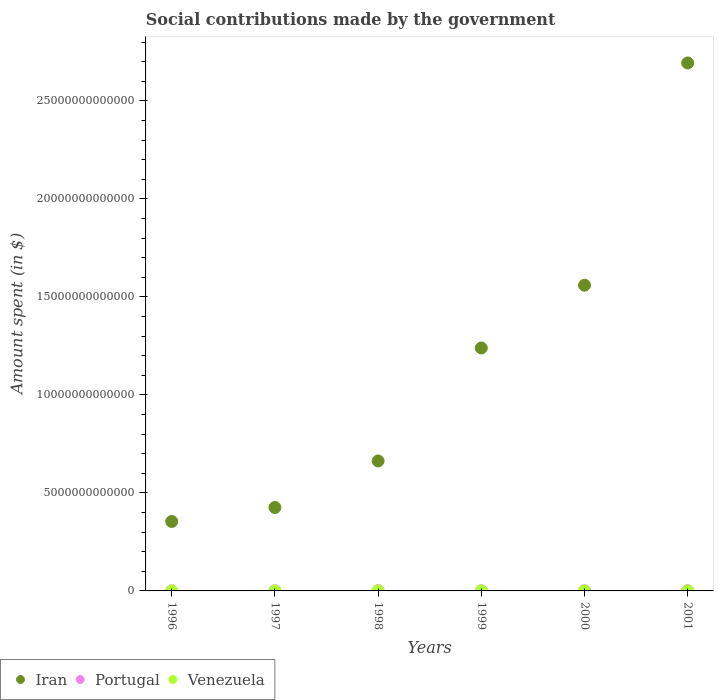How many different coloured dotlines are there?
Ensure brevity in your answer.  3. What is the amount spent on social contributions in Venezuela in 2000?
Offer a very short reply. 5.91e+08. Across all years, what is the maximum amount spent on social contributions in Portugal?
Provide a short and direct response. 1.42e+1. Across all years, what is the minimum amount spent on social contributions in Iran?
Give a very brief answer. 3.54e+12. What is the total amount spent on social contributions in Portugal in the graph?
Offer a very short reply. 6.99e+1. What is the difference between the amount spent on social contributions in Portugal in 1998 and that in 2001?
Make the answer very short. -3.02e+09. What is the difference between the amount spent on social contributions in Iran in 1999 and the amount spent on social contributions in Portugal in 2000?
Your response must be concise. 1.24e+13. What is the average amount spent on social contributions in Iran per year?
Your response must be concise. 1.16e+13. In the year 2001, what is the difference between the amount spent on social contributions in Portugal and amount spent on social contributions in Venezuela?
Your answer should be very brief. 1.36e+1. What is the ratio of the amount spent on social contributions in Venezuela in 1997 to that in 1999?
Your response must be concise. 0.33. Is the amount spent on social contributions in Portugal in 1997 less than that in 1999?
Offer a terse response. Yes. What is the difference between the highest and the second highest amount spent on social contributions in Portugal?
Offer a very short reply. 9.82e+08. What is the difference between the highest and the lowest amount spent on social contributions in Portugal?
Your answer should be very brief. 5.11e+09. In how many years, is the amount spent on social contributions in Iran greater than the average amount spent on social contributions in Iran taken over all years?
Ensure brevity in your answer.  3. Is the sum of the amount spent on social contributions in Iran in 2000 and 2001 greater than the maximum amount spent on social contributions in Portugal across all years?
Provide a short and direct response. Yes. Is the amount spent on social contributions in Venezuela strictly less than the amount spent on social contributions in Iran over the years?
Your answer should be compact. Yes. How many years are there in the graph?
Your response must be concise. 6. What is the difference between two consecutive major ticks on the Y-axis?
Offer a terse response. 5.00e+12. Are the values on the major ticks of Y-axis written in scientific E-notation?
Offer a very short reply. No. Does the graph contain any zero values?
Provide a succinct answer. No. Does the graph contain grids?
Your response must be concise. No. What is the title of the graph?
Provide a short and direct response. Social contributions made by the government. Does "Faeroe Islands" appear as one of the legend labels in the graph?
Provide a succinct answer. No. What is the label or title of the X-axis?
Provide a short and direct response. Years. What is the label or title of the Y-axis?
Provide a succinct answer. Amount spent (in $). What is the Amount spent (in $) of Iran in 1996?
Your answer should be very brief. 3.54e+12. What is the Amount spent (in $) of Portugal in 1996?
Keep it short and to the point. 9.14e+09. What is the Amount spent (in $) in Venezuela in 1996?
Your answer should be compact. 9.45e+07. What is the Amount spent (in $) of Iran in 1997?
Provide a succinct answer. 4.26e+12. What is the Amount spent (in $) in Portugal in 1997?
Provide a succinct answer. 1.01e+1. What is the Amount spent (in $) in Venezuela in 1997?
Your response must be concise. 1.60e+08. What is the Amount spent (in $) of Iran in 1998?
Offer a terse response. 6.63e+12. What is the Amount spent (in $) of Portugal in 1998?
Keep it short and to the point. 1.12e+1. What is the Amount spent (in $) of Venezuela in 1998?
Offer a very short reply. 3.72e+08. What is the Amount spent (in $) of Iran in 1999?
Your answer should be very brief. 1.24e+13. What is the Amount spent (in $) of Portugal in 1999?
Your response must be concise. 1.19e+1. What is the Amount spent (in $) of Venezuela in 1999?
Offer a very short reply. 4.79e+08. What is the Amount spent (in $) of Iran in 2000?
Ensure brevity in your answer.  1.56e+13. What is the Amount spent (in $) of Portugal in 2000?
Offer a very short reply. 1.33e+1. What is the Amount spent (in $) of Venezuela in 2000?
Offer a very short reply. 5.91e+08. What is the Amount spent (in $) in Iran in 2001?
Give a very brief answer. 2.69e+13. What is the Amount spent (in $) of Portugal in 2001?
Offer a terse response. 1.42e+1. What is the Amount spent (in $) of Venezuela in 2001?
Your answer should be compact. 6.74e+08. Across all years, what is the maximum Amount spent (in $) of Iran?
Give a very brief answer. 2.69e+13. Across all years, what is the maximum Amount spent (in $) in Portugal?
Offer a terse response. 1.42e+1. Across all years, what is the maximum Amount spent (in $) of Venezuela?
Your response must be concise. 6.74e+08. Across all years, what is the minimum Amount spent (in $) in Iran?
Provide a succinct answer. 3.54e+12. Across all years, what is the minimum Amount spent (in $) in Portugal?
Offer a very short reply. 9.14e+09. Across all years, what is the minimum Amount spent (in $) in Venezuela?
Keep it short and to the point. 9.45e+07. What is the total Amount spent (in $) in Iran in the graph?
Provide a succinct answer. 6.94e+13. What is the total Amount spent (in $) in Portugal in the graph?
Ensure brevity in your answer.  6.99e+1. What is the total Amount spent (in $) of Venezuela in the graph?
Offer a terse response. 2.37e+09. What is the difference between the Amount spent (in $) in Iran in 1996 and that in 1997?
Your answer should be very brief. -7.13e+11. What is the difference between the Amount spent (in $) of Portugal in 1996 and that in 1997?
Make the answer very short. -9.70e+08. What is the difference between the Amount spent (in $) in Venezuela in 1996 and that in 1997?
Your response must be concise. -6.55e+07. What is the difference between the Amount spent (in $) of Iran in 1996 and that in 1998?
Offer a terse response. -3.09e+12. What is the difference between the Amount spent (in $) in Portugal in 1996 and that in 1998?
Ensure brevity in your answer.  -2.09e+09. What is the difference between the Amount spent (in $) of Venezuela in 1996 and that in 1998?
Offer a terse response. -2.78e+08. What is the difference between the Amount spent (in $) in Iran in 1996 and that in 1999?
Offer a very short reply. -8.85e+12. What is the difference between the Amount spent (in $) of Portugal in 1996 and that in 1999?
Offer a very short reply. -2.79e+09. What is the difference between the Amount spent (in $) in Venezuela in 1996 and that in 1999?
Make the answer very short. -3.85e+08. What is the difference between the Amount spent (in $) of Iran in 1996 and that in 2000?
Give a very brief answer. -1.21e+13. What is the difference between the Amount spent (in $) of Portugal in 1996 and that in 2000?
Keep it short and to the point. -4.13e+09. What is the difference between the Amount spent (in $) of Venezuela in 1996 and that in 2000?
Provide a short and direct response. -4.96e+08. What is the difference between the Amount spent (in $) in Iran in 1996 and that in 2001?
Give a very brief answer. -2.34e+13. What is the difference between the Amount spent (in $) of Portugal in 1996 and that in 2001?
Offer a terse response. -5.11e+09. What is the difference between the Amount spent (in $) in Venezuela in 1996 and that in 2001?
Provide a succinct answer. -5.79e+08. What is the difference between the Amount spent (in $) of Iran in 1997 and that in 1998?
Your answer should be compact. -2.38e+12. What is the difference between the Amount spent (in $) of Portugal in 1997 and that in 1998?
Provide a short and direct response. -1.12e+09. What is the difference between the Amount spent (in $) of Venezuela in 1997 and that in 1998?
Offer a very short reply. -2.12e+08. What is the difference between the Amount spent (in $) in Iran in 1997 and that in 1999?
Provide a short and direct response. -8.14e+12. What is the difference between the Amount spent (in $) in Portugal in 1997 and that in 1999?
Provide a short and direct response. -1.82e+09. What is the difference between the Amount spent (in $) of Venezuela in 1997 and that in 1999?
Provide a short and direct response. -3.19e+08. What is the difference between the Amount spent (in $) of Iran in 1997 and that in 2000?
Your response must be concise. -1.13e+13. What is the difference between the Amount spent (in $) in Portugal in 1997 and that in 2000?
Your response must be concise. -3.16e+09. What is the difference between the Amount spent (in $) in Venezuela in 1997 and that in 2000?
Ensure brevity in your answer.  -4.30e+08. What is the difference between the Amount spent (in $) of Iran in 1997 and that in 2001?
Your response must be concise. -2.27e+13. What is the difference between the Amount spent (in $) of Portugal in 1997 and that in 2001?
Provide a short and direct response. -4.14e+09. What is the difference between the Amount spent (in $) of Venezuela in 1997 and that in 2001?
Your answer should be compact. -5.14e+08. What is the difference between the Amount spent (in $) of Iran in 1998 and that in 1999?
Offer a terse response. -5.76e+12. What is the difference between the Amount spent (in $) in Portugal in 1998 and that in 1999?
Make the answer very short. -7.01e+08. What is the difference between the Amount spent (in $) of Venezuela in 1998 and that in 1999?
Your answer should be very brief. -1.07e+08. What is the difference between the Amount spent (in $) of Iran in 1998 and that in 2000?
Your answer should be compact. -8.97e+12. What is the difference between the Amount spent (in $) in Portugal in 1998 and that in 2000?
Your answer should be compact. -2.04e+09. What is the difference between the Amount spent (in $) in Venezuela in 1998 and that in 2000?
Keep it short and to the point. -2.18e+08. What is the difference between the Amount spent (in $) in Iran in 1998 and that in 2001?
Ensure brevity in your answer.  -2.03e+13. What is the difference between the Amount spent (in $) in Portugal in 1998 and that in 2001?
Your response must be concise. -3.02e+09. What is the difference between the Amount spent (in $) in Venezuela in 1998 and that in 2001?
Your response must be concise. -3.01e+08. What is the difference between the Amount spent (in $) of Iran in 1999 and that in 2000?
Provide a succinct answer. -3.20e+12. What is the difference between the Amount spent (in $) of Portugal in 1999 and that in 2000?
Ensure brevity in your answer.  -1.34e+09. What is the difference between the Amount spent (in $) of Venezuela in 1999 and that in 2000?
Ensure brevity in your answer.  -1.11e+08. What is the difference between the Amount spent (in $) in Iran in 1999 and that in 2001?
Your answer should be very brief. -1.45e+13. What is the difference between the Amount spent (in $) in Portugal in 1999 and that in 2001?
Provide a succinct answer. -2.32e+09. What is the difference between the Amount spent (in $) of Venezuela in 1999 and that in 2001?
Keep it short and to the point. -1.94e+08. What is the difference between the Amount spent (in $) of Iran in 2000 and that in 2001?
Offer a very short reply. -1.13e+13. What is the difference between the Amount spent (in $) in Portugal in 2000 and that in 2001?
Ensure brevity in your answer.  -9.82e+08. What is the difference between the Amount spent (in $) in Venezuela in 2000 and that in 2001?
Keep it short and to the point. -8.30e+07. What is the difference between the Amount spent (in $) of Iran in 1996 and the Amount spent (in $) of Portugal in 1997?
Provide a short and direct response. 3.53e+12. What is the difference between the Amount spent (in $) in Iran in 1996 and the Amount spent (in $) in Venezuela in 1997?
Your answer should be compact. 3.54e+12. What is the difference between the Amount spent (in $) in Portugal in 1996 and the Amount spent (in $) in Venezuela in 1997?
Offer a very short reply. 8.98e+09. What is the difference between the Amount spent (in $) in Iran in 1996 and the Amount spent (in $) in Portugal in 1998?
Give a very brief answer. 3.53e+12. What is the difference between the Amount spent (in $) of Iran in 1996 and the Amount spent (in $) of Venezuela in 1998?
Offer a very short reply. 3.54e+12. What is the difference between the Amount spent (in $) in Portugal in 1996 and the Amount spent (in $) in Venezuela in 1998?
Provide a succinct answer. 8.76e+09. What is the difference between the Amount spent (in $) in Iran in 1996 and the Amount spent (in $) in Portugal in 1999?
Make the answer very short. 3.53e+12. What is the difference between the Amount spent (in $) in Iran in 1996 and the Amount spent (in $) in Venezuela in 1999?
Keep it short and to the point. 3.54e+12. What is the difference between the Amount spent (in $) in Portugal in 1996 and the Amount spent (in $) in Venezuela in 1999?
Keep it short and to the point. 8.66e+09. What is the difference between the Amount spent (in $) in Iran in 1996 and the Amount spent (in $) in Portugal in 2000?
Provide a succinct answer. 3.53e+12. What is the difference between the Amount spent (in $) in Iran in 1996 and the Amount spent (in $) in Venezuela in 2000?
Give a very brief answer. 3.54e+12. What is the difference between the Amount spent (in $) of Portugal in 1996 and the Amount spent (in $) of Venezuela in 2000?
Provide a succinct answer. 8.55e+09. What is the difference between the Amount spent (in $) in Iran in 1996 and the Amount spent (in $) in Portugal in 2001?
Give a very brief answer. 3.53e+12. What is the difference between the Amount spent (in $) in Iran in 1996 and the Amount spent (in $) in Venezuela in 2001?
Provide a succinct answer. 3.54e+12. What is the difference between the Amount spent (in $) in Portugal in 1996 and the Amount spent (in $) in Venezuela in 2001?
Ensure brevity in your answer.  8.46e+09. What is the difference between the Amount spent (in $) in Iran in 1997 and the Amount spent (in $) in Portugal in 1998?
Make the answer very short. 4.25e+12. What is the difference between the Amount spent (in $) of Iran in 1997 and the Amount spent (in $) of Venezuela in 1998?
Your answer should be compact. 4.26e+12. What is the difference between the Amount spent (in $) of Portugal in 1997 and the Amount spent (in $) of Venezuela in 1998?
Provide a short and direct response. 9.74e+09. What is the difference between the Amount spent (in $) in Iran in 1997 and the Amount spent (in $) in Portugal in 1999?
Provide a succinct answer. 4.25e+12. What is the difference between the Amount spent (in $) in Iran in 1997 and the Amount spent (in $) in Venezuela in 1999?
Give a very brief answer. 4.26e+12. What is the difference between the Amount spent (in $) of Portugal in 1997 and the Amount spent (in $) of Venezuela in 1999?
Give a very brief answer. 9.63e+09. What is the difference between the Amount spent (in $) of Iran in 1997 and the Amount spent (in $) of Portugal in 2000?
Give a very brief answer. 4.24e+12. What is the difference between the Amount spent (in $) of Iran in 1997 and the Amount spent (in $) of Venezuela in 2000?
Your response must be concise. 4.26e+12. What is the difference between the Amount spent (in $) in Portugal in 1997 and the Amount spent (in $) in Venezuela in 2000?
Your answer should be compact. 9.52e+09. What is the difference between the Amount spent (in $) of Iran in 1997 and the Amount spent (in $) of Portugal in 2001?
Keep it short and to the point. 4.24e+12. What is the difference between the Amount spent (in $) in Iran in 1997 and the Amount spent (in $) in Venezuela in 2001?
Offer a terse response. 4.26e+12. What is the difference between the Amount spent (in $) in Portugal in 1997 and the Amount spent (in $) in Venezuela in 2001?
Offer a very short reply. 9.43e+09. What is the difference between the Amount spent (in $) of Iran in 1998 and the Amount spent (in $) of Portugal in 1999?
Your answer should be very brief. 6.62e+12. What is the difference between the Amount spent (in $) of Iran in 1998 and the Amount spent (in $) of Venezuela in 1999?
Ensure brevity in your answer.  6.63e+12. What is the difference between the Amount spent (in $) of Portugal in 1998 and the Amount spent (in $) of Venezuela in 1999?
Ensure brevity in your answer.  1.07e+1. What is the difference between the Amount spent (in $) in Iran in 1998 and the Amount spent (in $) in Portugal in 2000?
Offer a terse response. 6.62e+12. What is the difference between the Amount spent (in $) in Iran in 1998 and the Amount spent (in $) in Venezuela in 2000?
Provide a succinct answer. 6.63e+12. What is the difference between the Amount spent (in $) in Portugal in 1998 and the Amount spent (in $) in Venezuela in 2000?
Provide a succinct answer. 1.06e+1. What is the difference between the Amount spent (in $) of Iran in 1998 and the Amount spent (in $) of Portugal in 2001?
Ensure brevity in your answer.  6.62e+12. What is the difference between the Amount spent (in $) of Iran in 1998 and the Amount spent (in $) of Venezuela in 2001?
Offer a terse response. 6.63e+12. What is the difference between the Amount spent (in $) in Portugal in 1998 and the Amount spent (in $) in Venezuela in 2001?
Give a very brief answer. 1.06e+1. What is the difference between the Amount spent (in $) of Iran in 1999 and the Amount spent (in $) of Portugal in 2000?
Ensure brevity in your answer.  1.24e+13. What is the difference between the Amount spent (in $) of Iran in 1999 and the Amount spent (in $) of Venezuela in 2000?
Make the answer very short. 1.24e+13. What is the difference between the Amount spent (in $) in Portugal in 1999 and the Amount spent (in $) in Venezuela in 2000?
Your answer should be very brief. 1.13e+1. What is the difference between the Amount spent (in $) of Iran in 1999 and the Amount spent (in $) of Portugal in 2001?
Your answer should be compact. 1.24e+13. What is the difference between the Amount spent (in $) of Iran in 1999 and the Amount spent (in $) of Venezuela in 2001?
Your answer should be very brief. 1.24e+13. What is the difference between the Amount spent (in $) of Portugal in 1999 and the Amount spent (in $) of Venezuela in 2001?
Your answer should be very brief. 1.13e+1. What is the difference between the Amount spent (in $) of Iran in 2000 and the Amount spent (in $) of Portugal in 2001?
Your response must be concise. 1.56e+13. What is the difference between the Amount spent (in $) in Iran in 2000 and the Amount spent (in $) in Venezuela in 2001?
Give a very brief answer. 1.56e+13. What is the difference between the Amount spent (in $) in Portugal in 2000 and the Amount spent (in $) in Venezuela in 2001?
Offer a very short reply. 1.26e+1. What is the average Amount spent (in $) in Iran per year?
Make the answer very short. 1.16e+13. What is the average Amount spent (in $) of Portugal per year?
Make the answer very short. 1.17e+1. What is the average Amount spent (in $) of Venezuela per year?
Your answer should be very brief. 3.95e+08. In the year 1996, what is the difference between the Amount spent (in $) of Iran and Amount spent (in $) of Portugal?
Offer a terse response. 3.53e+12. In the year 1996, what is the difference between the Amount spent (in $) of Iran and Amount spent (in $) of Venezuela?
Your response must be concise. 3.54e+12. In the year 1996, what is the difference between the Amount spent (in $) of Portugal and Amount spent (in $) of Venezuela?
Your answer should be very brief. 9.04e+09. In the year 1997, what is the difference between the Amount spent (in $) of Iran and Amount spent (in $) of Portugal?
Provide a succinct answer. 4.25e+12. In the year 1997, what is the difference between the Amount spent (in $) of Iran and Amount spent (in $) of Venezuela?
Give a very brief answer. 4.26e+12. In the year 1997, what is the difference between the Amount spent (in $) of Portugal and Amount spent (in $) of Venezuela?
Offer a very short reply. 9.95e+09. In the year 1998, what is the difference between the Amount spent (in $) in Iran and Amount spent (in $) in Portugal?
Your answer should be compact. 6.62e+12. In the year 1998, what is the difference between the Amount spent (in $) in Iran and Amount spent (in $) in Venezuela?
Ensure brevity in your answer.  6.63e+12. In the year 1998, what is the difference between the Amount spent (in $) of Portugal and Amount spent (in $) of Venezuela?
Your answer should be compact. 1.09e+1. In the year 1999, what is the difference between the Amount spent (in $) in Iran and Amount spent (in $) in Portugal?
Provide a short and direct response. 1.24e+13. In the year 1999, what is the difference between the Amount spent (in $) of Iran and Amount spent (in $) of Venezuela?
Make the answer very short. 1.24e+13. In the year 1999, what is the difference between the Amount spent (in $) of Portugal and Amount spent (in $) of Venezuela?
Offer a terse response. 1.14e+1. In the year 2000, what is the difference between the Amount spent (in $) in Iran and Amount spent (in $) in Portugal?
Keep it short and to the point. 1.56e+13. In the year 2000, what is the difference between the Amount spent (in $) in Iran and Amount spent (in $) in Venezuela?
Make the answer very short. 1.56e+13. In the year 2000, what is the difference between the Amount spent (in $) of Portugal and Amount spent (in $) of Venezuela?
Your answer should be very brief. 1.27e+1. In the year 2001, what is the difference between the Amount spent (in $) of Iran and Amount spent (in $) of Portugal?
Keep it short and to the point. 2.69e+13. In the year 2001, what is the difference between the Amount spent (in $) of Iran and Amount spent (in $) of Venezuela?
Your response must be concise. 2.69e+13. In the year 2001, what is the difference between the Amount spent (in $) of Portugal and Amount spent (in $) of Venezuela?
Provide a short and direct response. 1.36e+1. What is the ratio of the Amount spent (in $) in Iran in 1996 to that in 1997?
Provide a short and direct response. 0.83. What is the ratio of the Amount spent (in $) in Portugal in 1996 to that in 1997?
Provide a succinct answer. 0.9. What is the ratio of the Amount spent (in $) of Venezuela in 1996 to that in 1997?
Your response must be concise. 0.59. What is the ratio of the Amount spent (in $) of Iran in 1996 to that in 1998?
Your answer should be compact. 0.53. What is the ratio of the Amount spent (in $) of Portugal in 1996 to that in 1998?
Provide a succinct answer. 0.81. What is the ratio of the Amount spent (in $) in Venezuela in 1996 to that in 1998?
Provide a succinct answer. 0.25. What is the ratio of the Amount spent (in $) in Iran in 1996 to that in 1999?
Your answer should be very brief. 0.29. What is the ratio of the Amount spent (in $) in Portugal in 1996 to that in 1999?
Your answer should be very brief. 0.77. What is the ratio of the Amount spent (in $) in Venezuela in 1996 to that in 1999?
Offer a terse response. 0.2. What is the ratio of the Amount spent (in $) of Iran in 1996 to that in 2000?
Offer a very short reply. 0.23. What is the ratio of the Amount spent (in $) in Portugal in 1996 to that in 2000?
Provide a succinct answer. 0.69. What is the ratio of the Amount spent (in $) of Venezuela in 1996 to that in 2000?
Ensure brevity in your answer.  0.16. What is the ratio of the Amount spent (in $) in Iran in 1996 to that in 2001?
Your answer should be compact. 0.13. What is the ratio of the Amount spent (in $) in Portugal in 1996 to that in 2001?
Give a very brief answer. 0.64. What is the ratio of the Amount spent (in $) in Venezuela in 1996 to that in 2001?
Keep it short and to the point. 0.14. What is the ratio of the Amount spent (in $) of Iran in 1997 to that in 1998?
Provide a succinct answer. 0.64. What is the ratio of the Amount spent (in $) of Portugal in 1997 to that in 1998?
Your response must be concise. 0.9. What is the ratio of the Amount spent (in $) of Venezuela in 1997 to that in 1998?
Ensure brevity in your answer.  0.43. What is the ratio of the Amount spent (in $) of Iran in 1997 to that in 1999?
Give a very brief answer. 0.34. What is the ratio of the Amount spent (in $) in Portugal in 1997 to that in 1999?
Offer a terse response. 0.85. What is the ratio of the Amount spent (in $) in Venezuela in 1997 to that in 1999?
Offer a very short reply. 0.33. What is the ratio of the Amount spent (in $) of Iran in 1997 to that in 2000?
Give a very brief answer. 0.27. What is the ratio of the Amount spent (in $) in Portugal in 1997 to that in 2000?
Offer a very short reply. 0.76. What is the ratio of the Amount spent (in $) in Venezuela in 1997 to that in 2000?
Your answer should be very brief. 0.27. What is the ratio of the Amount spent (in $) in Iran in 1997 to that in 2001?
Ensure brevity in your answer.  0.16. What is the ratio of the Amount spent (in $) in Portugal in 1997 to that in 2001?
Your response must be concise. 0.71. What is the ratio of the Amount spent (in $) of Venezuela in 1997 to that in 2001?
Your response must be concise. 0.24. What is the ratio of the Amount spent (in $) of Iran in 1998 to that in 1999?
Keep it short and to the point. 0.54. What is the ratio of the Amount spent (in $) in Venezuela in 1998 to that in 1999?
Make the answer very short. 0.78. What is the ratio of the Amount spent (in $) in Iran in 1998 to that in 2000?
Provide a short and direct response. 0.43. What is the ratio of the Amount spent (in $) in Portugal in 1998 to that in 2000?
Give a very brief answer. 0.85. What is the ratio of the Amount spent (in $) in Venezuela in 1998 to that in 2000?
Give a very brief answer. 0.63. What is the ratio of the Amount spent (in $) in Iran in 1998 to that in 2001?
Offer a very short reply. 0.25. What is the ratio of the Amount spent (in $) in Portugal in 1998 to that in 2001?
Provide a short and direct response. 0.79. What is the ratio of the Amount spent (in $) in Venezuela in 1998 to that in 2001?
Your response must be concise. 0.55. What is the ratio of the Amount spent (in $) of Iran in 1999 to that in 2000?
Provide a short and direct response. 0.79. What is the ratio of the Amount spent (in $) of Portugal in 1999 to that in 2000?
Your response must be concise. 0.9. What is the ratio of the Amount spent (in $) of Venezuela in 1999 to that in 2000?
Your answer should be very brief. 0.81. What is the ratio of the Amount spent (in $) in Iran in 1999 to that in 2001?
Ensure brevity in your answer.  0.46. What is the ratio of the Amount spent (in $) of Portugal in 1999 to that in 2001?
Your answer should be compact. 0.84. What is the ratio of the Amount spent (in $) in Venezuela in 1999 to that in 2001?
Make the answer very short. 0.71. What is the ratio of the Amount spent (in $) of Iran in 2000 to that in 2001?
Offer a terse response. 0.58. What is the ratio of the Amount spent (in $) of Portugal in 2000 to that in 2001?
Give a very brief answer. 0.93. What is the ratio of the Amount spent (in $) of Venezuela in 2000 to that in 2001?
Offer a very short reply. 0.88. What is the difference between the highest and the second highest Amount spent (in $) in Iran?
Give a very brief answer. 1.13e+13. What is the difference between the highest and the second highest Amount spent (in $) in Portugal?
Provide a short and direct response. 9.82e+08. What is the difference between the highest and the second highest Amount spent (in $) in Venezuela?
Offer a very short reply. 8.30e+07. What is the difference between the highest and the lowest Amount spent (in $) of Iran?
Your answer should be compact. 2.34e+13. What is the difference between the highest and the lowest Amount spent (in $) of Portugal?
Ensure brevity in your answer.  5.11e+09. What is the difference between the highest and the lowest Amount spent (in $) of Venezuela?
Your response must be concise. 5.79e+08. 